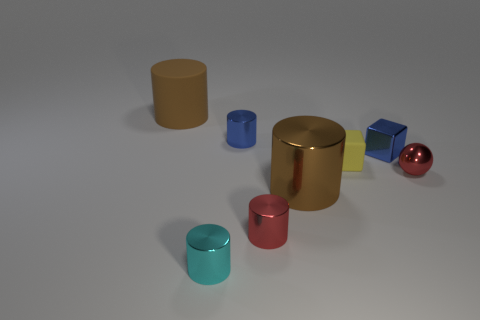Does the tiny red cylinder have the same material as the small blue cylinder?
Your response must be concise. Yes. How many things are large brown cylinders that are behind the blue cube or large objects that are to the left of the big metallic object?
Your answer should be very brief. 1. There is another small thing that is the same shape as the small yellow matte thing; what color is it?
Provide a succinct answer. Blue. What number of shiny objects have the same color as the small metal cube?
Ensure brevity in your answer.  1. Is the big rubber cylinder the same color as the big metallic object?
Your answer should be compact. Yes. What number of objects are brown objects in front of the tiny yellow rubber cube or small cyan cylinders?
Make the answer very short. 2. There is a tiny metallic object that is in front of the tiny cylinder on the right side of the tiny cylinder that is behind the shiny ball; what is its color?
Make the answer very short. Cyan. There is a ball that is made of the same material as the small blue block; what is its color?
Your answer should be very brief. Red. What number of blocks are the same material as the blue cylinder?
Provide a succinct answer. 1. Is the size of the cyan metallic cylinder that is on the left side of the blue block the same as the large metallic cylinder?
Your response must be concise. No. 